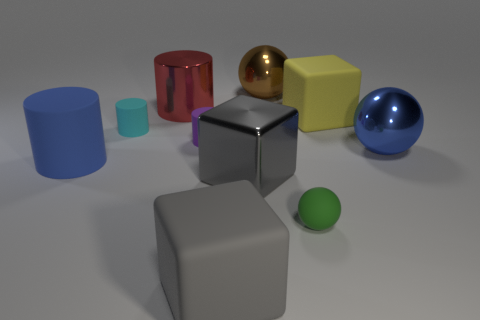Subtract all balls. How many objects are left? 7 Add 3 small green shiny things. How many small green shiny things exist? 3 Subtract 1 blue spheres. How many objects are left? 9 Subtract all big cylinders. Subtract all red shiny objects. How many objects are left? 7 Add 5 yellow matte things. How many yellow matte things are left? 6 